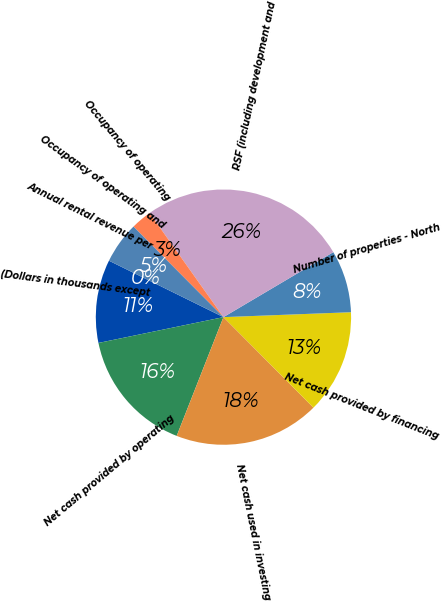Convert chart. <chart><loc_0><loc_0><loc_500><loc_500><pie_chart><fcel>(Dollars in thousands except<fcel>Net cash provided by operating<fcel>Net cash used in investing<fcel>Net cash provided by financing<fcel>Number of properties - North<fcel>RSF (including development and<fcel>Occupancy of operating<fcel>Occupancy of operating and<fcel>Annual rental revenue per<nl><fcel>10.53%<fcel>15.79%<fcel>18.42%<fcel>13.16%<fcel>7.89%<fcel>26.32%<fcel>2.63%<fcel>5.26%<fcel>0.0%<nl></chart> 